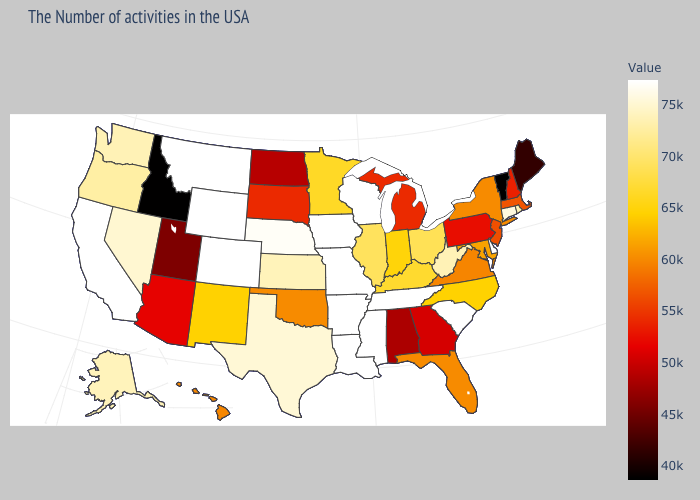Among the states that border Louisiana , which have the highest value?
Write a very short answer. Mississippi, Arkansas. Among the states that border South Carolina , which have the lowest value?
Keep it brief. Georgia. Which states have the lowest value in the USA?
Concise answer only. Vermont. Which states have the lowest value in the USA?
Give a very brief answer. Vermont. Does Virginia have a lower value than New Hampshire?
Concise answer only. No. Which states hav the highest value in the South?
Be succinct. Delaware, South Carolina, Tennessee, Mississippi, Louisiana, Arkansas. Does Kentucky have the lowest value in the USA?
Be succinct. No. Does Maine have the highest value in the USA?
Quick response, please. No. 